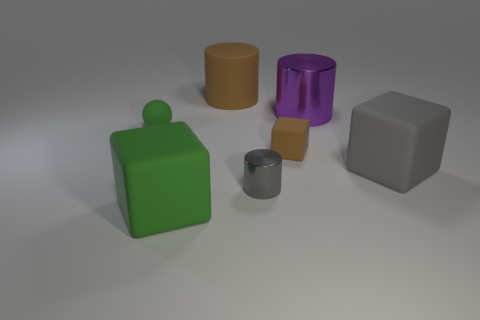Add 1 large green matte cylinders. How many objects exist? 8 Subtract all blocks. How many objects are left? 4 Subtract all green spheres. Subtract all tiny green spheres. How many objects are left? 5 Add 4 purple metal things. How many purple metal things are left? 5 Add 7 green objects. How many green objects exist? 9 Subtract 1 brown cylinders. How many objects are left? 6 